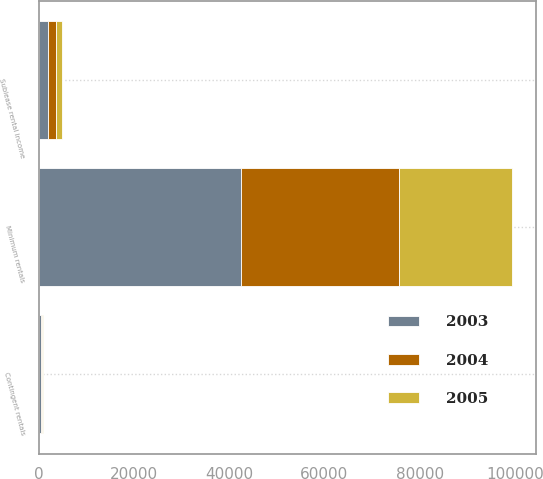<chart> <loc_0><loc_0><loc_500><loc_500><stacked_bar_chart><ecel><fcel>Minimum rentals<fcel>Contingent rentals<fcel>Sublease rental income<nl><fcel>2003<fcel>42506<fcel>431<fcel>2070<nl><fcel>2004<fcel>33201<fcel>284<fcel>1632<nl><fcel>2005<fcel>23688<fcel>196<fcel>1143<nl></chart> 